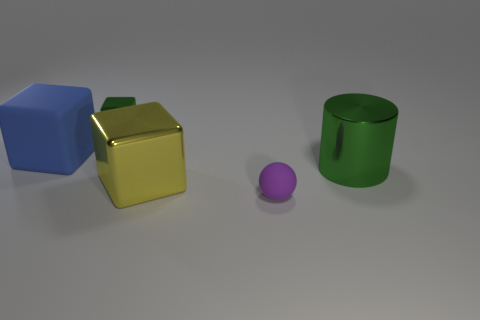Add 1 tiny red metallic blocks. How many objects exist? 6 Subtract all cylinders. How many objects are left? 4 Add 1 small shiny objects. How many small shiny objects are left? 2 Add 4 tiny shiny cubes. How many tiny shiny cubes exist? 5 Subtract 0 green spheres. How many objects are left? 5 Subtract all green shiny cylinders. Subtract all big yellow blocks. How many objects are left? 3 